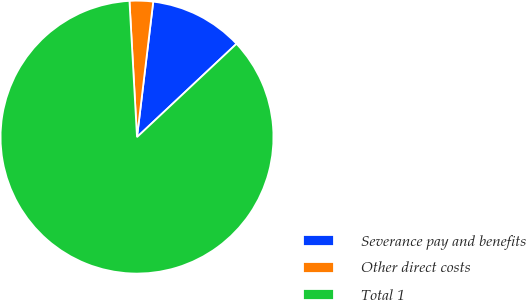<chart> <loc_0><loc_0><loc_500><loc_500><pie_chart><fcel>Severance pay and benefits<fcel>Other direct costs<fcel>Total 1<nl><fcel>11.11%<fcel>2.78%<fcel>86.11%<nl></chart> 